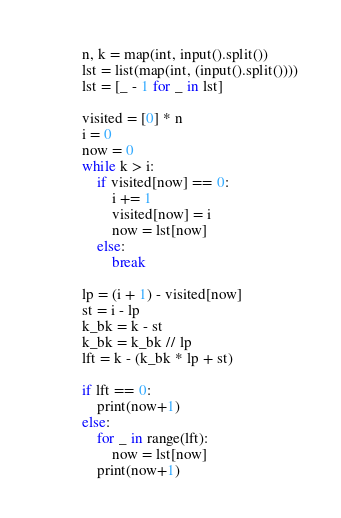<code> <loc_0><loc_0><loc_500><loc_500><_Python_>n, k = map(int, input().split())
lst = list(map(int, (input().split())))
lst = [_ - 1 for _ in lst]

visited = [0] * n
i = 0
now = 0
while k > i:
    if visited[now] == 0:
        i += 1
        visited[now] = i
        now = lst[now] 
    else:
        break

lp = (i + 1) - visited[now]
st = i - lp
k_bk = k - st
k_bk = k_bk // lp
lft = k - (k_bk * lp + st)

if lft == 0:
    print(now+1)
else:
    for _ in range(lft):
        now = lst[now]
    print(now+1)
</code> 